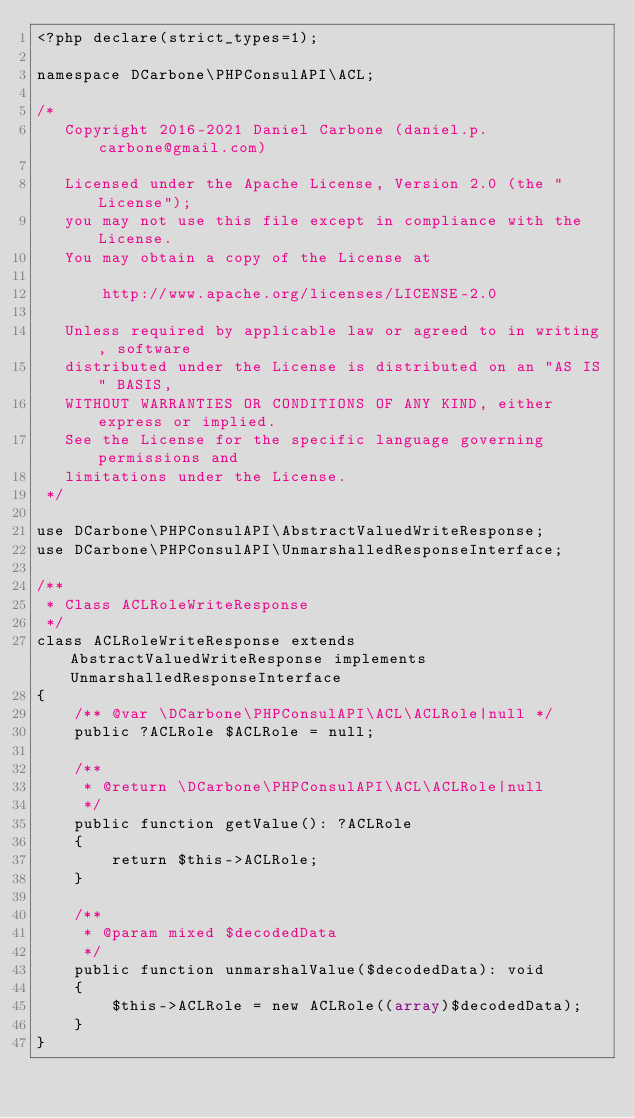<code> <loc_0><loc_0><loc_500><loc_500><_PHP_><?php declare(strict_types=1);

namespace DCarbone\PHPConsulAPI\ACL;

/*
   Copyright 2016-2021 Daniel Carbone (daniel.p.carbone@gmail.com)

   Licensed under the Apache License, Version 2.0 (the "License");
   you may not use this file except in compliance with the License.
   You may obtain a copy of the License at

       http://www.apache.org/licenses/LICENSE-2.0

   Unless required by applicable law or agreed to in writing, software
   distributed under the License is distributed on an "AS IS" BASIS,
   WITHOUT WARRANTIES OR CONDITIONS OF ANY KIND, either express or implied.
   See the License for the specific language governing permissions and
   limitations under the License.
 */

use DCarbone\PHPConsulAPI\AbstractValuedWriteResponse;
use DCarbone\PHPConsulAPI\UnmarshalledResponseInterface;

/**
 * Class ACLRoleWriteResponse
 */
class ACLRoleWriteResponse extends AbstractValuedWriteResponse implements UnmarshalledResponseInterface
{
    /** @var \DCarbone\PHPConsulAPI\ACL\ACLRole|null */
    public ?ACLRole $ACLRole = null;

    /**
     * @return \DCarbone\PHPConsulAPI\ACL\ACLRole|null
     */
    public function getValue(): ?ACLRole
    {
        return $this->ACLRole;
    }

    /**
     * @param mixed $decodedData
     */
    public function unmarshalValue($decodedData): void
    {
        $this->ACLRole = new ACLRole((array)$decodedData);
    }
}
</code> 